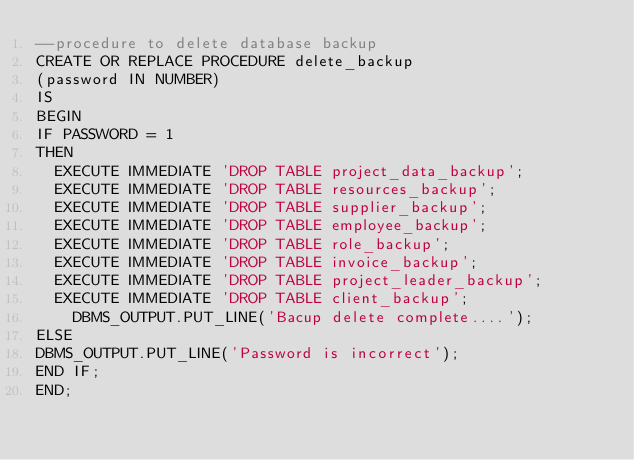<code> <loc_0><loc_0><loc_500><loc_500><_SQL_>--procedure to delete database backup
CREATE OR REPLACE PROCEDURE delete_backup
(password IN NUMBER)
IS 
BEGIN
IF PASSWORD = 1
THEN
  EXECUTE IMMEDIATE 'DROP TABLE project_data_backup'; 
  EXECUTE IMMEDIATE 'DROP TABLE resources_backup';
  EXECUTE IMMEDIATE 'DROP TABLE supplier_backup';
  EXECUTE IMMEDIATE 'DROP TABLE employee_backup'; 
  EXECUTE IMMEDIATE 'DROP TABLE role_backup';
  EXECUTE IMMEDIATE 'DROP TABLE invoice_backup';	  
  EXECUTE IMMEDIATE 'DROP TABLE project_leader_backup';
  EXECUTE IMMEDIATE 'DROP TABLE client_backup';
	DBMS_OUTPUT.PUT_LINE('Bacup delete complete....');
ELSE 
DBMS_OUTPUT.PUT_LINE('Password is incorrect');
END IF;
END;</code> 